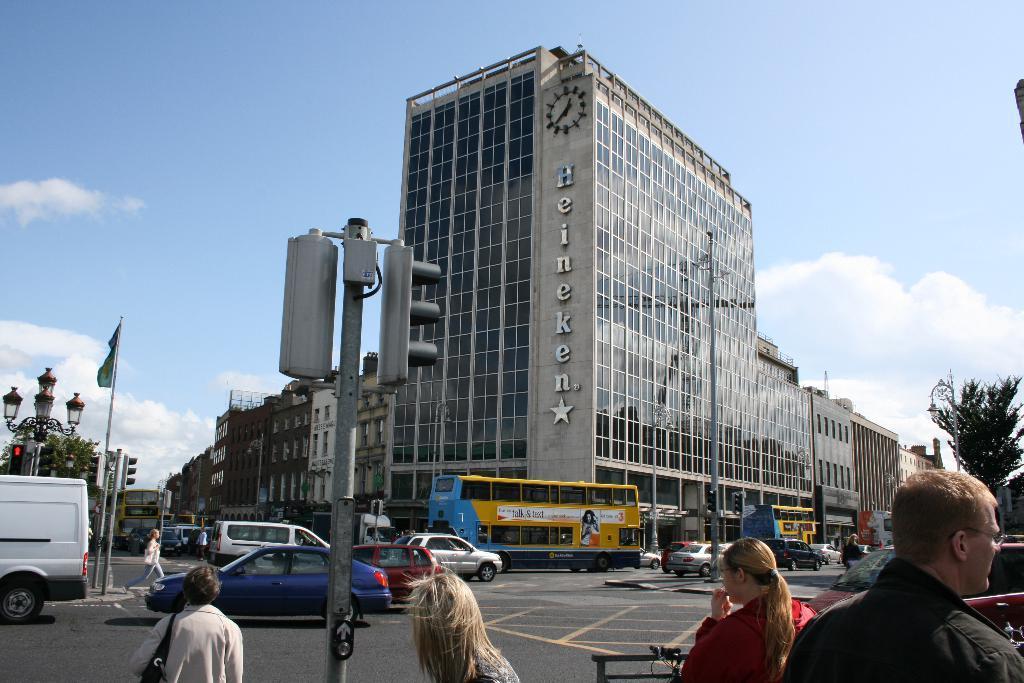In one or two sentences, can you explain what this image depicts? In this image I can see a main road , on the road I can see vehicle s and traffic signal light and street light poles and buildings, at the top I can see the sky and at the bottom I can see persons and I can see a woman walking on the road in the middle. On the right side I can see a tree. 